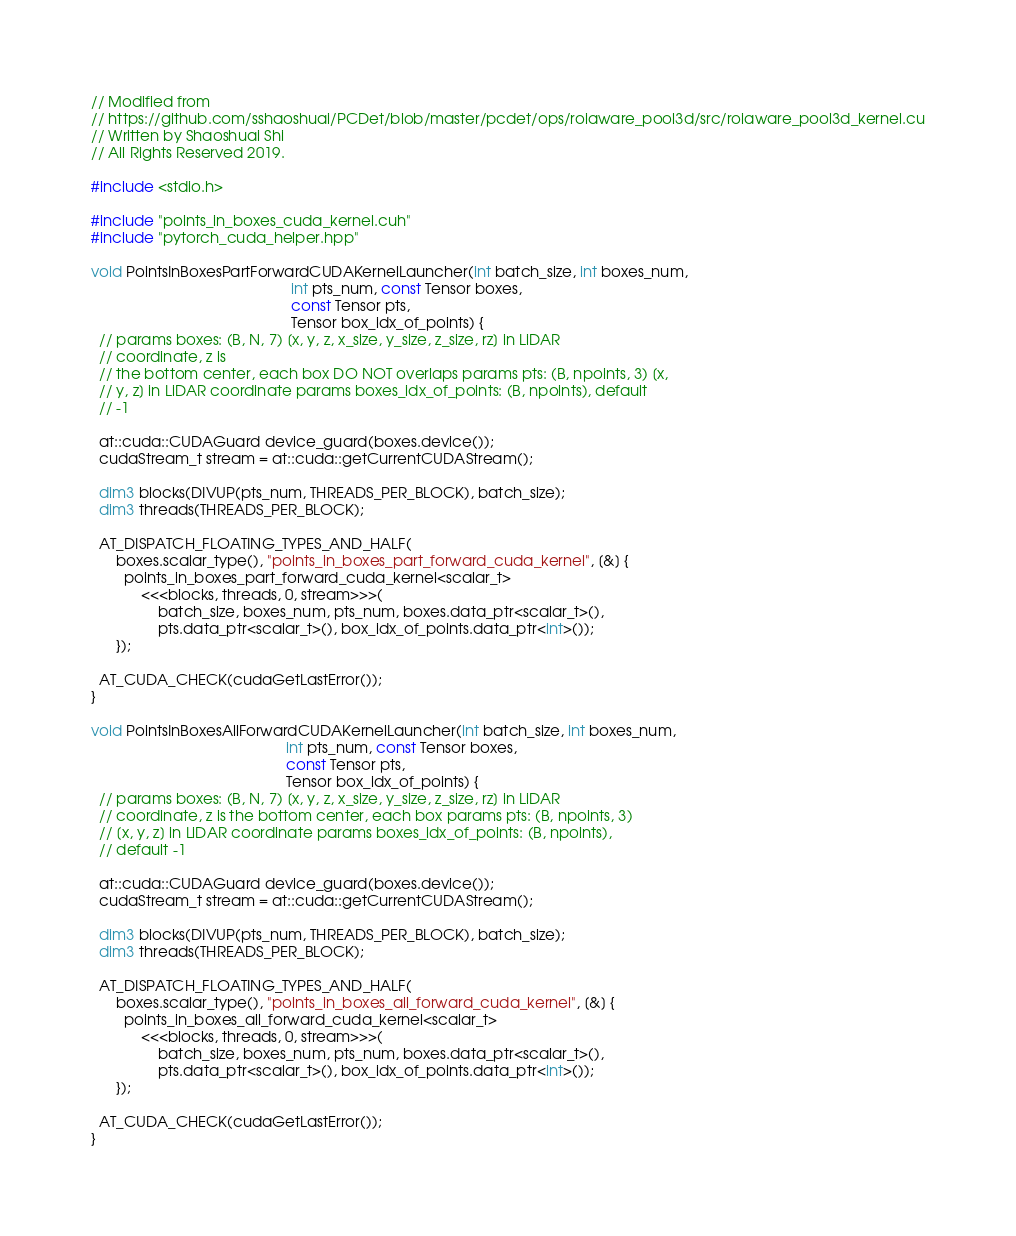<code> <loc_0><loc_0><loc_500><loc_500><_Cuda_>// Modified from
// https://github.com/sshaoshuai/PCDet/blob/master/pcdet/ops/roiaware_pool3d/src/roiaware_pool3d_kernel.cu
// Written by Shaoshuai Shi
// All Rights Reserved 2019.

#include <stdio.h>

#include "points_in_boxes_cuda_kernel.cuh"
#include "pytorch_cuda_helper.hpp"

void PointsInBoxesPartForwardCUDAKernelLauncher(int batch_size, int boxes_num,
                                                int pts_num, const Tensor boxes,
                                                const Tensor pts,
                                                Tensor box_idx_of_points) {
  // params boxes: (B, N, 7) [x, y, z, x_size, y_size, z_size, rz] in LiDAR
  // coordinate, z is
  // the bottom center, each box DO NOT overlaps params pts: (B, npoints, 3) [x,
  // y, z] in LiDAR coordinate params boxes_idx_of_points: (B, npoints), default
  // -1

  at::cuda::CUDAGuard device_guard(boxes.device());
  cudaStream_t stream = at::cuda::getCurrentCUDAStream();

  dim3 blocks(DIVUP(pts_num, THREADS_PER_BLOCK), batch_size);
  dim3 threads(THREADS_PER_BLOCK);

  AT_DISPATCH_FLOATING_TYPES_AND_HALF(
      boxes.scalar_type(), "points_in_boxes_part_forward_cuda_kernel", [&] {
        points_in_boxes_part_forward_cuda_kernel<scalar_t>
            <<<blocks, threads, 0, stream>>>(
                batch_size, boxes_num, pts_num, boxes.data_ptr<scalar_t>(),
                pts.data_ptr<scalar_t>(), box_idx_of_points.data_ptr<int>());
      });

  AT_CUDA_CHECK(cudaGetLastError());
}

void PointsInBoxesAllForwardCUDAKernelLauncher(int batch_size, int boxes_num,
                                               int pts_num, const Tensor boxes,
                                               const Tensor pts,
                                               Tensor box_idx_of_points) {
  // params boxes: (B, N, 7) [x, y, z, x_size, y_size, z_size, rz] in LiDAR
  // coordinate, z is the bottom center, each box params pts: (B, npoints, 3)
  // [x, y, z] in LiDAR coordinate params boxes_idx_of_points: (B, npoints),
  // default -1

  at::cuda::CUDAGuard device_guard(boxes.device());
  cudaStream_t stream = at::cuda::getCurrentCUDAStream();

  dim3 blocks(DIVUP(pts_num, THREADS_PER_BLOCK), batch_size);
  dim3 threads(THREADS_PER_BLOCK);

  AT_DISPATCH_FLOATING_TYPES_AND_HALF(
      boxes.scalar_type(), "points_in_boxes_all_forward_cuda_kernel", [&] {
        points_in_boxes_all_forward_cuda_kernel<scalar_t>
            <<<blocks, threads, 0, stream>>>(
                batch_size, boxes_num, pts_num, boxes.data_ptr<scalar_t>(),
                pts.data_ptr<scalar_t>(), box_idx_of_points.data_ptr<int>());
      });

  AT_CUDA_CHECK(cudaGetLastError());
}
</code> 